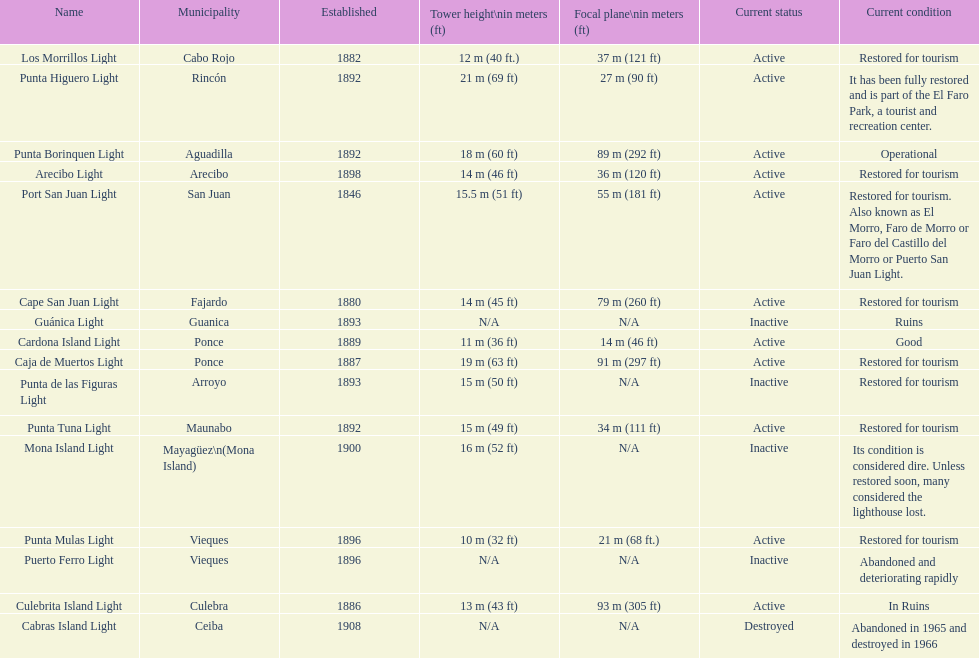What count of establishments have been refurbished to cater to tourists? 9. 